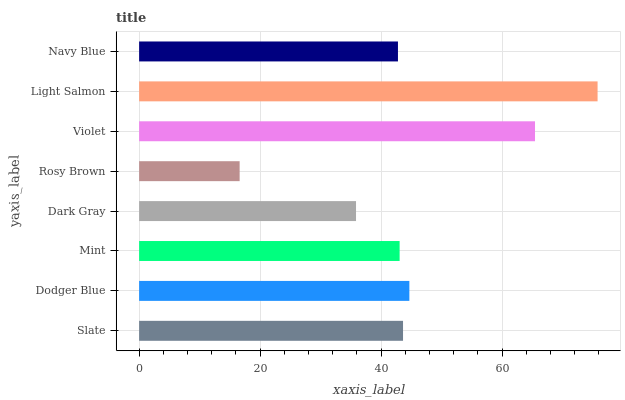Is Rosy Brown the minimum?
Answer yes or no. Yes. Is Light Salmon the maximum?
Answer yes or no. Yes. Is Dodger Blue the minimum?
Answer yes or no. No. Is Dodger Blue the maximum?
Answer yes or no. No. Is Dodger Blue greater than Slate?
Answer yes or no. Yes. Is Slate less than Dodger Blue?
Answer yes or no. Yes. Is Slate greater than Dodger Blue?
Answer yes or no. No. Is Dodger Blue less than Slate?
Answer yes or no. No. Is Slate the high median?
Answer yes or no. Yes. Is Mint the low median?
Answer yes or no. Yes. Is Light Salmon the high median?
Answer yes or no. No. Is Navy Blue the low median?
Answer yes or no. No. 